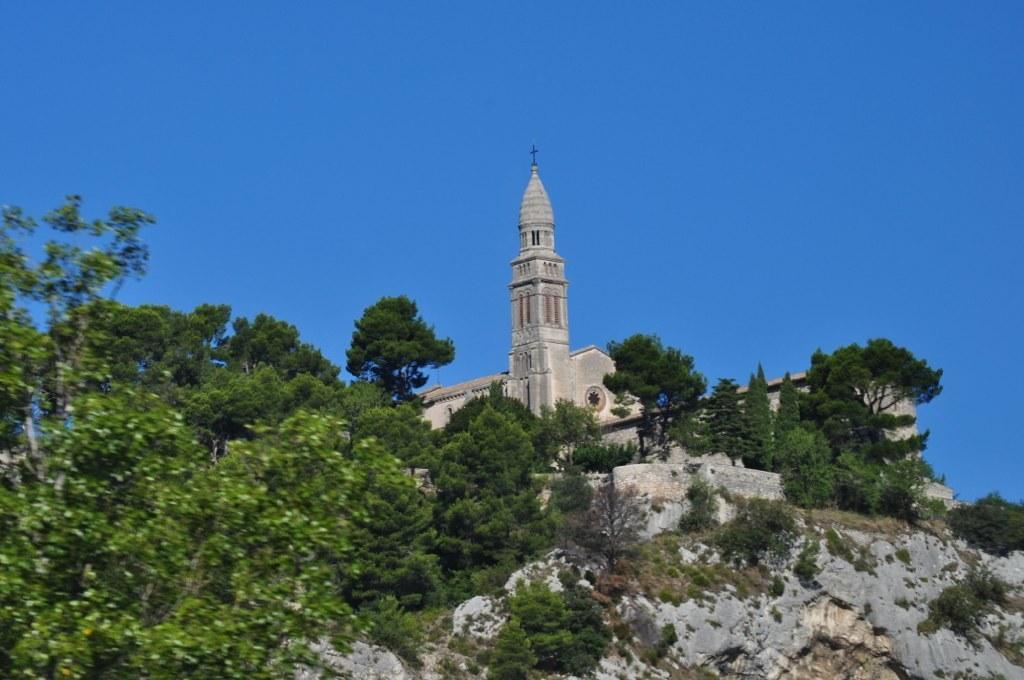How would you summarize this image in a sentence or two? In this image we can see a building. There are trees and rocks. In the background there is sky. 